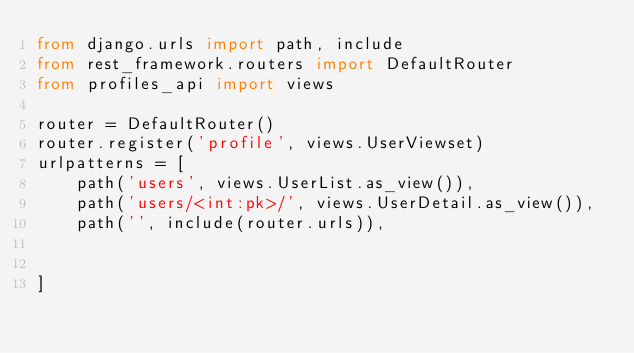<code> <loc_0><loc_0><loc_500><loc_500><_Python_>from django.urls import path, include
from rest_framework.routers import DefaultRouter
from profiles_api import views

router = DefaultRouter()
router.register('profile', views.UserViewset)
urlpatterns = [
    path('users', views.UserList.as_view()),
    path('users/<int:pk>/', views.UserDetail.as_view()),
    path('', include(router.urls)),


]</code> 